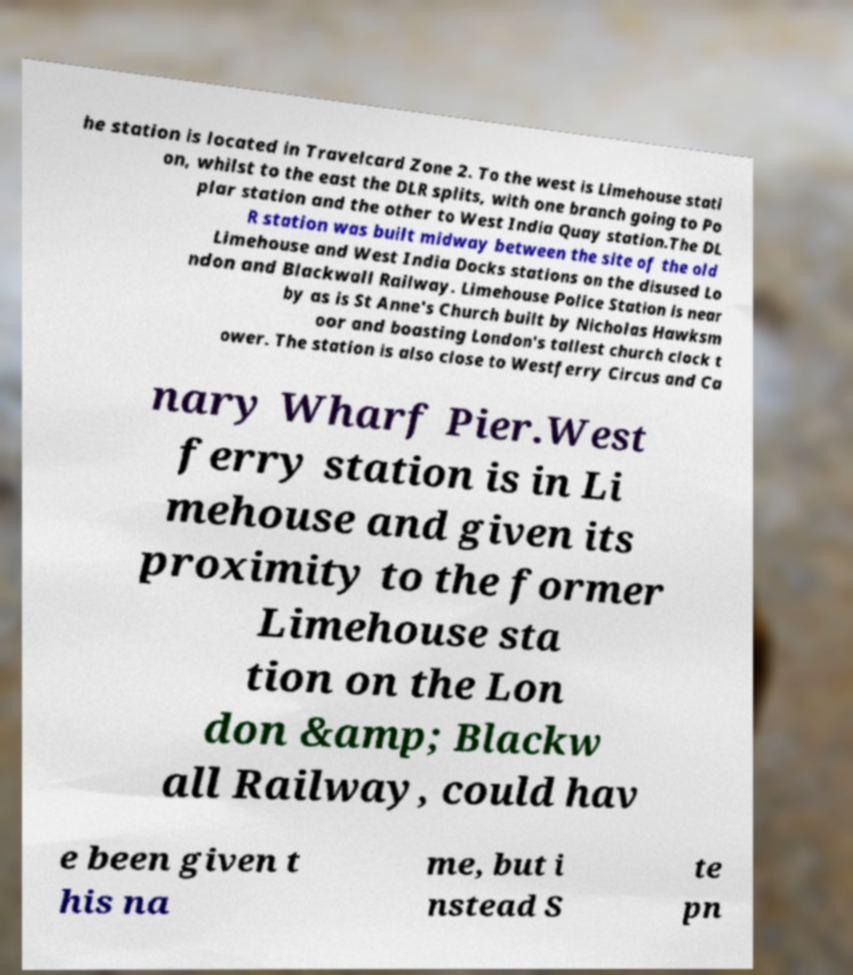Can you read and provide the text displayed in the image?This photo seems to have some interesting text. Can you extract and type it out for me? he station is located in Travelcard Zone 2. To the west is Limehouse stati on, whilst to the east the DLR splits, with one branch going to Po plar station and the other to West India Quay station.The DL R station was built midway between the site of the old Limehouse and West India Docks stations on the disused Lo ndon and Blackwall Railway. Limehouse Police Station is near by as is St Anne's Church built by Nicholas Hawksm oor and boasting London's tallest church clock t ower. The station is also close to Westferry Circus and Ca nary Wharf Pier.West ferry station is in Li mehouse and given its proximity to the former Limehouse sta tion on the Lon don &amp; Blackw all Railway, could hav e been given t his na me, but i nstead S te pn 